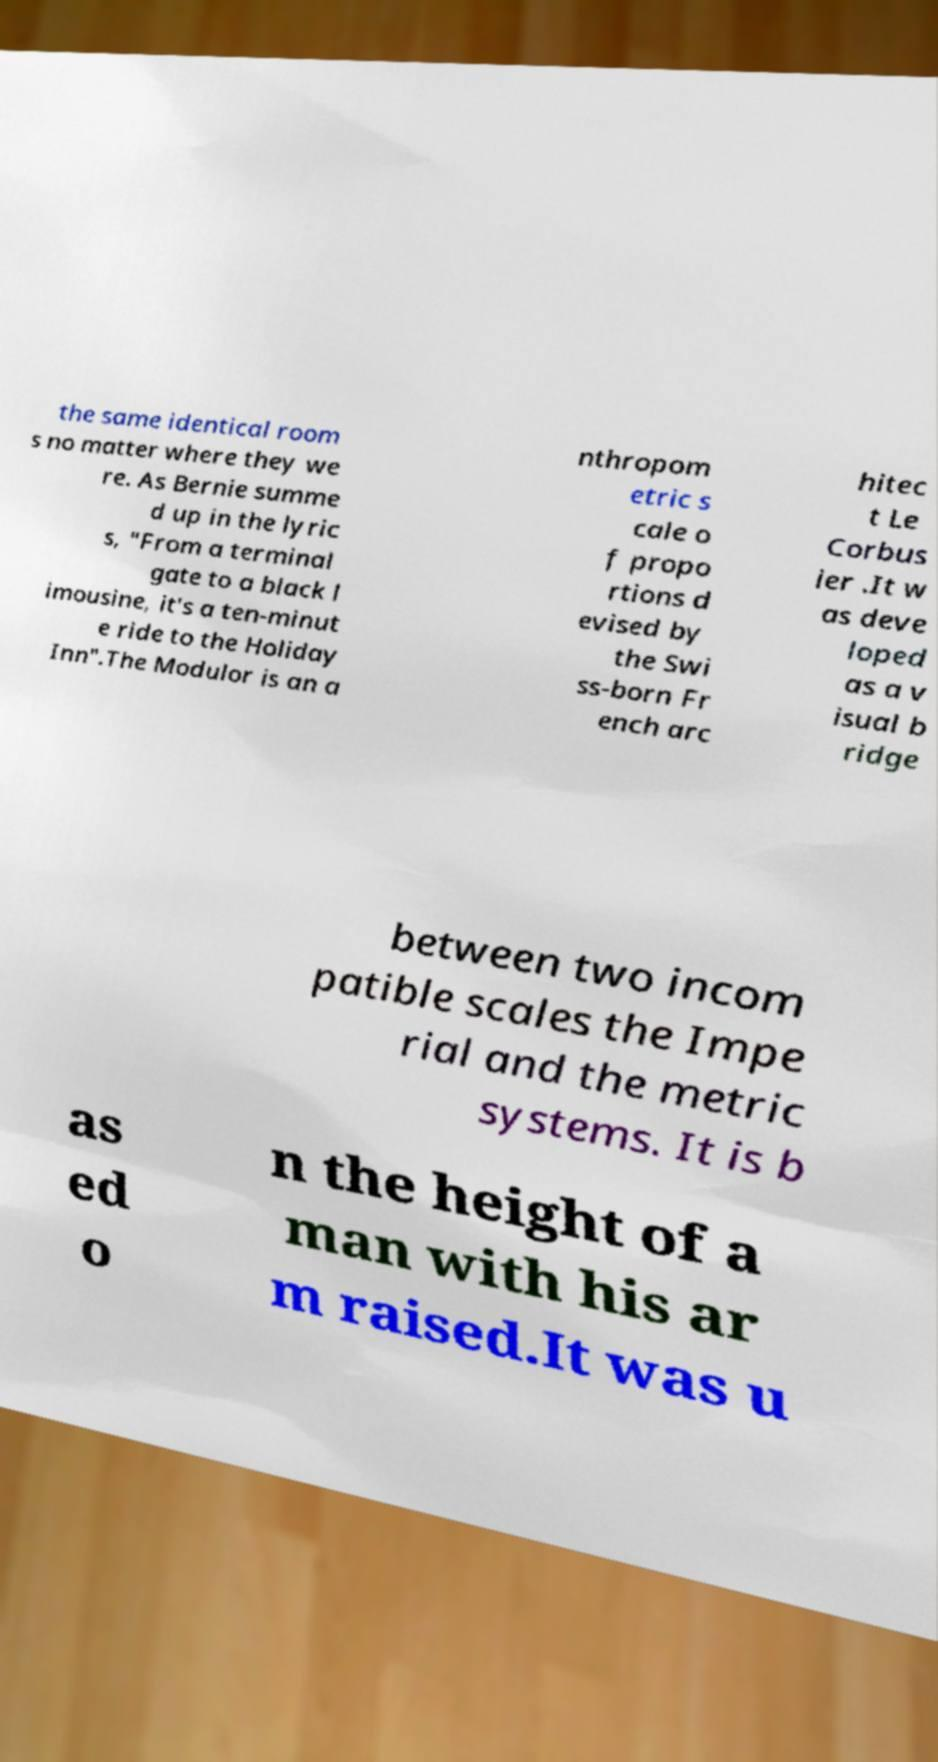Could you assist in decoding the text presented in this image and type it out clearly? the same identical room s no matter where they we re. As Bernie summe d up in the lyric s, "From a terminal gate to a black l imousine, it's a ten-minut e ride to the Holiday Inn".The Modulor is an a nthropom etric s cale o f propo rtions d evised by the Swi ss-born Fr ench arc hitec t Le Corbus ier .It w as deve loped as a v isual b ridge between two incom patible scales the Impe rial and the metric systems. It is b as ed o n the height of a man with his ar m raised.It was u 